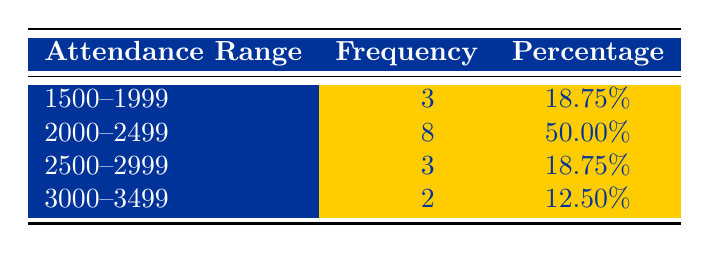What was the total attendance for Barrow A.F.C. home games with attendance between 2000 and 2499? To find the total attendance in this range, we need to sum the attendance values for the matches listed within that range: 2203, 2130, 2715, 2400, 2000, 2075, 2207, and 2185. The sum is (2203 + 2130 + 2400 + 2000 + 2075 + 2207 + 2185) = 13,000.
Answer: 13000 How many matches had an attendance of less than 2000? From the table, we can see that there are three matches with attendances in the range of 1500 to 1999, specifically: Dagenham & Redbridge (1500), Bromley (1950), and Wealdstone (1850). Hence, the total number of matches with attendance below 2000 is 3.
Answer: 3 What is the percentage of matches that had an attendance of 2500 or more? To determine this percentage, we first see how many matches had an attendance of 2500 or more: Wrexham (3001), Notts County (2750), Southend United (2715), and Oldham Athletic (3005), totaling 4 matches. Next, we take the total number of matches, which is 16. The percentage is (4/16) * 100 = 25%.
Answer: 25% Did Barrow A.F.C. have any matches with an attendance above 3000? Looking at the table, there are two matches with attendances of 3001 and 3005, which means there were matches with attendances above 3000.
Answer: Yes What was the most frequent attendance range for matches? According to the table, the most frequent attendance range is 2000-2499, with a frequency of 8 matches, which makes it the highest among the listed ranges.
Answer: 2000-2499 How would you describe the trend of match attendance over the range of attendance levels? The frequency distribution shows that more than half of the matches (50.00%) fall within the 2000-2499 range, while only 12.50% had attendance figures above 3000, indicating a concentration of attendance levels below 2500. This suggests that while some matches can draw larger crowds, the majority still tend to attract moderate turnouts.
Answer: Majority in 2000-2499 range 